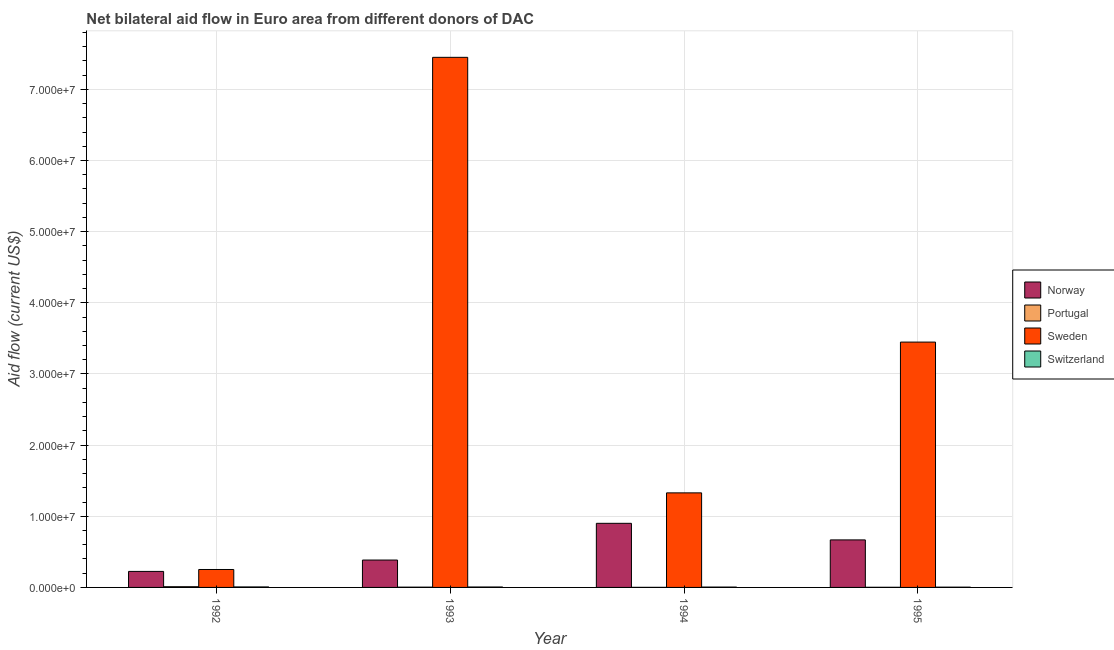Are the number of bars per tick equal to the number of legend labels?
Provide a succinct answer. Yes. How many bars are there on the 3rd tick from the right?
Your answer should be compact. 4. What is the label of the 2nd group of bars from the left?
Your answer should be very brief. 1993. In how many cases, is the number of bars for a given year not equal to the number of legend labels?
Give a very brief answer. 0. What is the amount of aid given by norway in 1993?
Offer a terse response. 3.85e+06. Across all years, what is the maximum amount of aid given by switzerland?
Ensure brevity in your answer.  7.00e+04. Across all years, what is the minimum amount of aid given by norway?
Offer a terse response. 2.25e+06. In which year was the amount of aid given by portugal maximum?
Provide a succinct answer. 1992. What is the total amount of aid given by sweden in the graph?
Provide a succinct answer. 1.25e+08. What is the difference between the amount of aid given by sweden in 1992 and that in 1993?
Your answer should be very brief. -7.20e+07. What is the difference between the amount of aid given by portugal in 1995 and the amount of aid given by norway in 1994?
Provide a succinct answer. 10000. What is the average amount of aid given by switzerland per year?
Make the answer very short. 5.50e+04. What is the ratio of the amount of aid given by switzerland in 1992 to that in 1995?
Offer a very short reply. 1.75. Is the amount of aid given by switzerland in 1994 less than that in 1995?
Keep it short and to the point. No. Is the difference between the amount of aid given by switzerland in 1992 and 1993 greater than the difference between the amount of aid given by norway in 1992 and 1993?
Your response must be concise. No. What is the difference between the highest and the second highest amount of aid given by switzerland?
Offer a very short reply. 10000. What is the difference between the highest and the lowest amount of aid given by switzerland?
Keep it short and to the point. 3.00e+04. In how many years, is the amount of aid given by switzerland greater than the average amount of aid given by switzerland taken over all years?
Provide a short and direct response. 2. Is it the case that in every year, the sum of the amount of aid given by norway and amount of aid given by portugal is greater than the sum of amount of aid given by switzerland and amount of aid given by sweden?
Your answer should be compact. Yes. What does the 1st bar from the left in 1992 represents?
Ensure brevity in your answer.  Norway. What does the 3rd bar from the right in 1993 represents?
Your response must be concise. Portugal. How many bars are there?
Ensure brevity in your answer.  16. Are the values on the major ticks of Y-axis written in scientific E-notation?
Give a very brief answer. Yes. How are the legend labels stacked?
Make the answer very short. Vertical. What is the title of the graph?
Offer a very short reply. Net bilateral aid flow in Euro area from different donors of DAC. What is the label or title of the X-axis?
Ensure brevity in your answer.  Year. What is the label or title of the Y-axis?
Make the answer very short. Aid flow (current US$). What is the Aid flow (current US$) of Norway in 1992?
Provide a succinct answer. 2.25e+06. What is the Aid flow (current US$) of Portugal in 1992?
Your answer should be very brief. 1.00e+05. What is the Aid flow (current US$) of Sweden in 1992?
Provide a succinct answer. 2.52e+06. What is the Aid flow (current US$) of Switzerland in 1992?
Ensure brevity in your answer.  7.00e+04. What is the Aid flow (current US$) of Norway in 1993?
Ensure brevity in your answer.  3.85e+06. What is the Aid flow (current US$) in Portugal in 1993?
Make the answer very short. 4.00e+04. What is the Aid flow (current US$) in Sweden in 1993?
Offer a very short reply. 7.45e+07. What is the Aid flow (current US$) in Switzerland in 1993?
Make the answer very short. 6.00e+04. What is the Aid flow (current US$) in Norway in 1994?
Ensure brevity in your answer.  9.01e+06. What is the Aid flow (current US$) in Sweden in 1994?
Your response must be concise. 1.33e+07. What is the Aid flow (current US$) of Switzerland in 1994?
Your answer should be very brief. 5.00e+04. What is the Aid flow (current US$) of Norway in 1995?
Give a very brief answer. 6.68e+06. What is the Aid flow (current US$) in Portugal in 1995?
Provide a succinct answer. 2.00e+04. What is the Aid flow (current US$) of Sweden in 1995?
Your response must be concise. 3.45e+07. Across all years, what is the maximum Aid flow (current US$) in Norway?
Offer a very short reply. 9.01e+06. Across all years, what is the maximum Aid flow (current US$) in Portugal?
Provide a short and direct response. 1.00e+05. Across all years, what is the maximum Aid flow (current US$) in Sweden?
Your answer should be compact. 7.45e+07. Across all years, what is the minimum Aid flow (current US$) of Norway?
Keep it short and to the point. 2.25e+06. Across all years, what is the minimum Aid flow (current US$) of Portugal?
Provide a succinct answer. 10000. Across all years, what is the minimum Aid flow (current US$) of Sweden?
Your answer should be very brief. 2.52e+06. Across all years, what is the minimum Aid flow (current US$) in Switzerland?
Your response must be concise. 4.00e+04. What is the total Aid flow (current US$) in Norway in the graph?
Your response must be concise. 2.18e+07. What is the total Aid flow (current US$) of Portugal in the graph?
Provide a succinct answer. 1.70e+05. What is the total Aid flow (current US$) of Sweden in the graph?
Your response must be concise. 1.25e+08. What is the difference between the Aid flow (current US$) in Norway in 1992 and that in 1993?
Your response must be concise. -1.60e+06. What is the difference between the Aid flow (current US$) of Portugal in 1992 and that in 1993?
Provide a short and direct response. 6.00e+04. What is the difference between the Aid flow (current US$) of Sweden in 1992 and that in 1993?
Keep it short and to the point. -7.20e+07. What is the difference between the Aid flow (current US$) in Switzerland in 1992 and that in 1993?
Provide a succinct answer. 10000. What is the difference between the Aid flow (current US$) in Norway in 1992 and that in 1994?
Make the answer very short. -6.76e+06. What is the difference between the Aid flow (current US$) in Portugal in 1992 and that in 1994?
Give a very brief answer. 9.00e+04. What is the difference between the Aid flow (current US$) in Sweden in 1992 and that in 1994?
Make the answer very short. -1.08e+07. What is the difference between the Aid flow (current US$) of Norway in 1992 and that in 1995?
Make the answer very short. -4.43e+06. What is the difference between the Aid flow (current US$) of Sweden in 1992 and that in 1995?
Keep it short and to the point. -3.20e+07. What is the difference between the Aid flow (current US$) of Norway in 1993 and that in 1994?
Provide a short and direct response. -5.16e+06. What is the difference between the Aid flow (current US$) in Portugal in 1993 and that in 1994?
Offer a terse response. 3.00e+04. What is the difference between the Aid flow (current US$) in Sweden in 1993 and that in 1994?
Provide a short and direct response. 6.12e+07. What is the difference between the Aid flow (current US$) of Norway in 1993 and that in 1995?
Offer a terse response. -2.83e+06. What is the difference between the Aid flow (current US$) in Sweden in 1993 and that in 1995?
Your response must be concise. 4.00e+07. What is the difference between the Aid flow (current US$) in Switzerland in 1993 and that in 1995?
Offer a terse response. 2.00e+04. What is the difference between the Aid flow (current US$) of Norway in 1994 and that in 1995?
Your response must be concise. 2.33e+06. What is the difference between the Aid flow (current US$) of Sweden in 1994 and that in 1995?
Give a very brief answer. -2.12e+07. What is the difference between the Aid flow (current US$) in Switzerland in 1994 and that in 1995?
Provide a short and direct response. 10000. What is the difference between the Aid flow (current US$) of Norway in 1992 and the Aid flow (current US$) of Portugal in 1993?
Your response must be concise. 2.21e+06. What is the difference between the Aid flow (current US$) in Norway in 1992 and the Aid flow (current US$) in Sweden in 1993?
Keep it short and to the point. -7.22e+07. What is the difference between the Aid flow (current US$) in Norway in 1992 and the Aid flow (current US$) in Switzerland in 1993?
Ensure brevity in your answer.  2.19e+06. What is the difference between the Aid flow (current US$) of Portugal in 1992 and the Aid flow (current US$) of Sweden in 1993?
Offer a terse response. -7.44e+07. What is the difference between the Aid flow (current US$) in Sweden in 1992 and the Aid flow (current US$) in Switzerland in 1993?
Your response must be concise. 2.46e+06. What is the difference between the Aid flow (current US$) of Norway in 1992 and the Aid flow (current US$) of Portugal in 1994?
Provide a short and direct response. 2.24e+06. What is the difference between the Aid flow (current US$) of Norway in 1992 and the Aid flow (current US$) of Sweden in 1994?
Offer a very short reply. -1.10e+07. What is the difference between the Aid flow (current US$) in Norway in 1992 and the Aid flow (current US$) in Switzerland in 1994?
Your answer should be very brief. 2.20e+06. What is the difference between the Aid flow (current US$) in Portugal in 1992 and the Aid flow (current US$) in Sweden in 1994?
Provide a short and direct response. -1.32e+07. What is the difference between the Aid flow (current US$) in Sweden in 1992 and the Aid flow (current US$) in Switzerland in 1994?
Ensure brevity in your answer.  2.47e+06. What is the difference between the Aid flow (current US$) in Norway in 1992 and the Aid flow (current US$) in Portugal in 1995?
Ensure brevity in your answer.  2.23e+06. What is the difference between the Aid flow (current US$) in Norway in 1992 and the Aid flow (current US$) in Sweden in 1995?
Provide a short and direct response. -3.22e+07. What is the difference between the Aid flow (current US$) in Norway in 1992 and the Aid flow (current US$) in Switzerland in 1995?
Offer a very short reply. 2.21e+06. What is the difference between the Aid flow (current US$) in Portugal in 1992 and the Aid flow (current US$) in Sweden in 1995?
Ensure brevity in your answer.  -3.44e+07. What is the difference between the Aid flow (current US$) of Portugal in 1992 and the Aid flow (current US$) of Switzerland in 1995?
Ensure brevity in your answer.  6.00e+04. What is the difference between the Aid flow (current US$) of Sweden in 1992 and the Aid flow (current US$) of Switzerland in 1995?
Keep it short and to the point. 2.48e+06. What is the difference between the Aid flow (current US$) of Norway in 1993 and the Aid flow (current US$) of Portugal in 1994?
Your response must be concise. 3.84e+06. What is the difference between the Aid flow (current US$) of Norway in 1993 and the Aid flow (current US$) of Sweden in 1994?
Your answer should be compact. -9.44e+06. What is the difference between the Aid flow (current US$) of Norway in 1993 and the Aid flow (current US$) of Switzerland in 1994?
Offer a very short reply. 3.80e+06. What is the difference between the Aid flow (current US$) of Portugal in 1993 and the Aid flow (current US$) of Sweden in 1994?
Provide a short and direct response. -1.32e+07. What is the difference between the Aid flow (current US$) of Sweden in 1993 and the Aid flow (current US$) of Switzerland in 1994?
Offer a terse response. 7.44e+07. What is the difference between the Aid flow (current US$) in Norway in 1993 and the Aid flow (current US$) in Portugal in 1995?
Ensure brevity in your answer.  3.83e+06. What is the difference between the Aid flow (current US$) of Norway in 1993 and the Aid flow (current US$) of Sweden in 1995?
Keep it short and to the point. -3.06e+07. What is the difference between the Aid flow (current US$) in Norway in 1993 and the Aid flow (current US$) in Switzerland in 1995?
Your response must be concise. 3.81e+06. What is the difference between the Aid flow (current US$) of Portugal in 1993 and the Aid flow (current US$) of Sweden in 1995?
Offer a very short reply. -3.44e+07. What is the difference between the Aid flow (current US$) in Portugal in 1993 and the Aid flow (current US$) in Switzerland in 1995?
Offer a very short reply. 0. What is the difference between the Aid flow (current US$) of Sweden in 1993 and the Aid flow (current US$) of Switzerland in 1995?
Your answer should be very brief. 7.45e+07. What is the difference between the Aid flow (current US$) in Norway in 1994 and the Aid flow (current US$) in Portugal in 1995?
Provide a succinct answer. 8.99e+06. What is the difference between the Aid flow (current US$) of Norway in 1994 and the Aid flow (current US$) of Sweden in 1995?
Your answer should be very brief. -2.55e+07. What is the difference between the Aid flow (current US$) of Norway in 1994 and the Aid flow (current US$) of Switzerland in 1995?
Your answer should be very brief. 8.97e+06. What is the difference between the Aid flow (current US$) of Portugal in 1994 and the Aid flow (current US$) of Sweden in 1995?
Offer a terse response. -3.45e+07. What is the difference between the Aid flow (current US$) of Sweden in 1994 and the Aid flow (current US$) of Switzerland in 1995?
Offer a terse response. 1.32e+07. What is the average Aid flow (current US$) of Norway per year?
Give a very brief answer. 5.45e+06. What is the average Aid flow (current US$) in Portugal per year?
Keep it short and to the point. 4.25e+04. What is the average Aid flow (current US$) of Sweden per year?
Your answer should be very brief. 3.12e+07. What is the average Aid flow (current US$) in Switzerland per year?
Ensure brevity in your answer.  5.50e+04. In the year 1992, what is the difference between the Aid flow (current US$) in Norway and Aid flow (current US$) in Portugal?
Your answer should be compact. 2.15e+06. In the year 1992, what is the difference between the Aid flow (current US$) in Norway and Aid flow (current US$) in Switzerland?
Your answer should be compact. 2.18e+06. In the year 1992, what is the difference between the Aid flow (current US$) in Portugal and Aid flow (current US$) in Sweden?
Your response must be concise. -2.42e+06. In the year 1992, what is the difference between the Aid flow (current US$) of Portugal and Aid flow (current US$) of Switzerland?
Your response must be concise. 3.00e+04. In the year 1992, what is the difference between the Aid flow (current US$) of Sweden and Aid flow (current US$) of Switzerland?
Your answer should be compact. 2.45e+06. In the year 1993, what is the difference between the Aid flow (current US$) of Norway and Aid flow (current US$) of Portugal?
Offer a terse response. 3.81e+06. In the year 1993, what is the difference between the Aid flow (current US$) of Norway and Aid flow (current US$) of Sweden?
Your answer should be compact. -7.06e+07. In the year 1993, what is the difference between the Aid flow (current US$) in Norway and Aid flow (current US$) in Switzerland?
Provide a short and direct response. 3.79e+06. In the year 1993, what is the difference between the Aid flow (current US$) of Portugal and Aid flow (current US$) of Sweden?
Make the answer very short. -7.45e+07. In the year 1993, what is the difference between the Aid flow (current US$) in Sweden and Aid flow (current US$) in Switzerland?
Offer a very short reply. 7.44e+07. In the year 1994, what is the difference between the Aid flow (current US$) in Norway and Aid flow (current US$) in Portugal?
Your answer should be very brief. 9.00e+06. In the year 1994, what is the difference between the Aid flow (current US$) of Norway and Aid flow (current US$) of Sweden?
Your response must be concise. -4.28e+06. In the year 1994, what is the difference between the Aid flow (current US$) in Norway and Aid flow (current US$) in Switzerland?
Ensure brevity in your answer.  8.96e+06. In the year 1994, what is the difference between the Aid flow (current US$) in Portugal and Aid flow (current US$) in Sweden?
Your answer should be compact. -1.33e+07. In the year 1994, what is the difference between the Aid flow (current US$) of Sweden and Aid flow (current US$) of Switzerland?
Keep it short and to the point. 1.32e+07. In the year 1995, what is the difference between the Aid flow (current US$) of Norway and Aid flow (current US$) of Portugal?
Offer a terse response. 6.66e+06. In the year 1995, what is the difference between the Aid flow (current US$) in Norway and Aid flow (current US$) in Sweden?
Your answer should be very brief. -2.78e+07. In the year 1995, what is the difference between the Aid flow (current US$) of Norway and Aid flow (current US$) of Switzerland?
Offer a very short reply. 6.64e+06. In the year 1995, what is the difference between the Aid flow (current US$) of Portugal and Aid flow (current US$) of Sweden?
Provide a succinct answer. -3.45e+07. In the year 1995, what is the difference between the Aid flow (current US$) of Sweden and Aid flow (current US$) of Switzerland?
Make the answer very short. 3.44e+07. What is the ratio of the Aid flow (current US$) of Norway in 1992 to that in 1993?
Your answer should be very brief. 0.58. What is the ratio of the Aid flow (current US$) of Sweden in 1992 to that in 1993?
Your answer should be compact. 0.03. What is the ratio of the Aid flow (current US$) in Switzerland in 1992 to that in 1993?
Provide a short and direct response. 1.17. What is the ratio of the Aid flow (current US$) of Norway in 1992 to that in 1994?
Offer a very short reply. 0.25. What is the ratio of the Aid flow (current US$) in Sweden in 1992 to that in 1994?
Your answer should be compact. 0.19. What is the ratio of the Aid flow (current US$) in Norway in 1992 to that in 1995?
Your response must be concise. 0.34. What is the ratio of the Aid flow (current US$) of Sweden in 1992 to that in 1995?
Ensure brevity in your answer.  0.07. What is the ratio of the Aid flow (current US$) of Norway in 1993 to that in 1994?
Offer a very short reply. 0.43. What is the ratio of the Aid flow (current US$) of Portugal in 1993 to that in 1994?
Provide a succinct answer. 4. What is the ratio of the Aid flow (current US$) of Sweden in 1993 to that in 1994?
Give a very brief answer. 5.61. What is the ratio of the Aid flow (current US$) in Norway in 1993 to that in 1995?
Make the answer very short. 0.58. What is the ratio of the Aid flow (current US$) in Sweden in 1993 to that in 1995?
Make the answer very short. 2.16. What is the ratio of the Aid flow (current US$) in Norway in 1994 to that in 1995?
Offer a terse response. 1.35. What is the ratio of the Aid flow (current US$) in Portugal in 1994 to that in 1995?
Your answer should be compact. 0.5. What is the ratio of the Aid flow (current US$) in Sweden in 1994 to that in 1995?
Your answer should be compact. 0.39. What is the difference between the highest and the second highest Aid flow (current US$) of Norway?
Make the answer very short. 2.33e+06. What is the difference between the highest and the second highest Aid flow (current US$) of Sweden?
Provide a short and direct response. 4.00e+07. What is the difference between the highest and the lowest Aid flow (current US$) in Norway?
Provide a succinct answer. 6.76e+06. What is the difference between the highest and the lowest Aid flow (current US$) in Portugal?
Offer a very short reply. 9.00e+04. What is the difference between the highest and the lowest Aid flow (current US$) in Sweden?
Keep it short and to the point. 7.20e+07. 